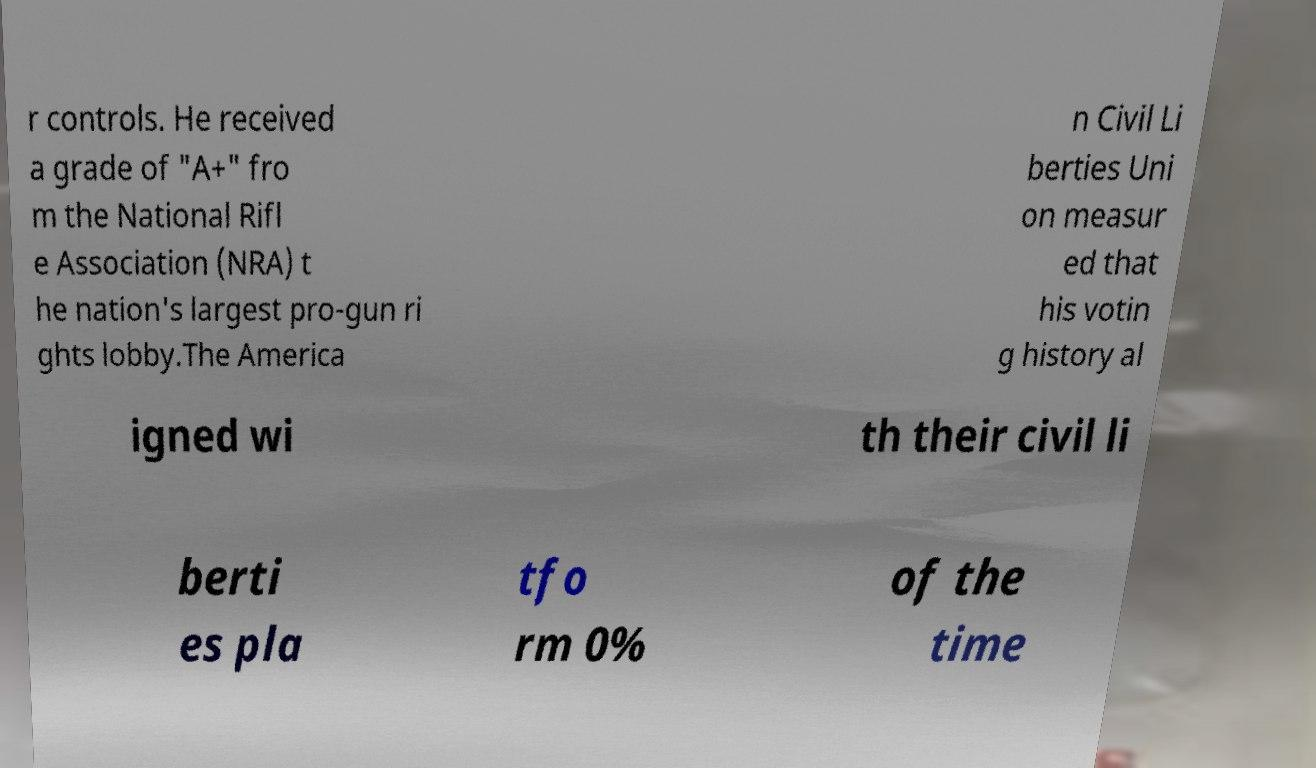Can you read and provide the text displayed in the image?This photo seems to have some interesting text. Can you extract and type it out for me? r controls. He received a grade of "A+" fro m the National Rifl e Association (NRA) t he nation's largest pro-gun ri ghts lobby.The America n Civil Li berties Uni on measur ed that his votin g history al igned wi th their civil li berti es pla tfo rm 0% of the time 